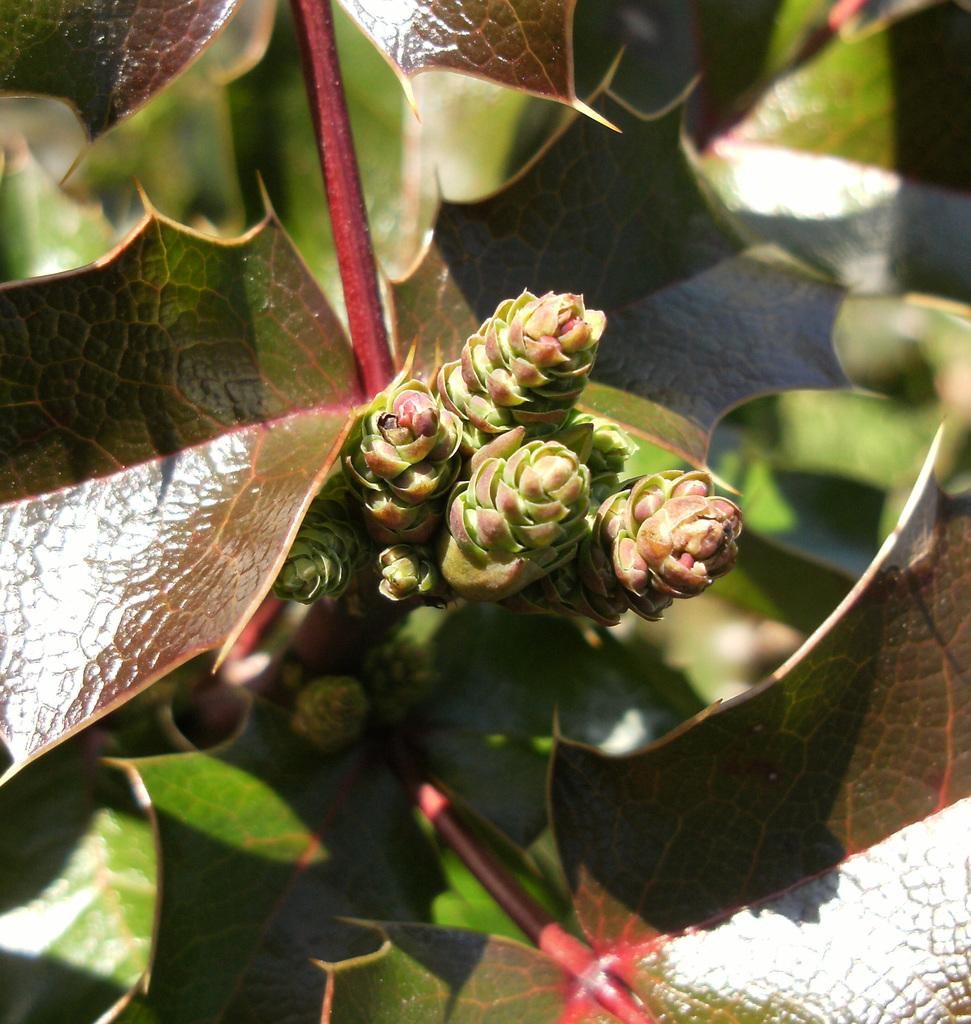What stage of growth are the buds on the plant in the image? The buds on the plant in the image are in the early stages of growth. What type of leaves can be seen at the bottom of the plant in the image? There are green leaves at the bottom of the plant in the image. What country is depicted in the image? The image does not depict a country; it features a plant with buds and green leaves. What day of the week is shown in the image? The image does not depict a specific day of the week; it features a plant with buds and green leaves. 